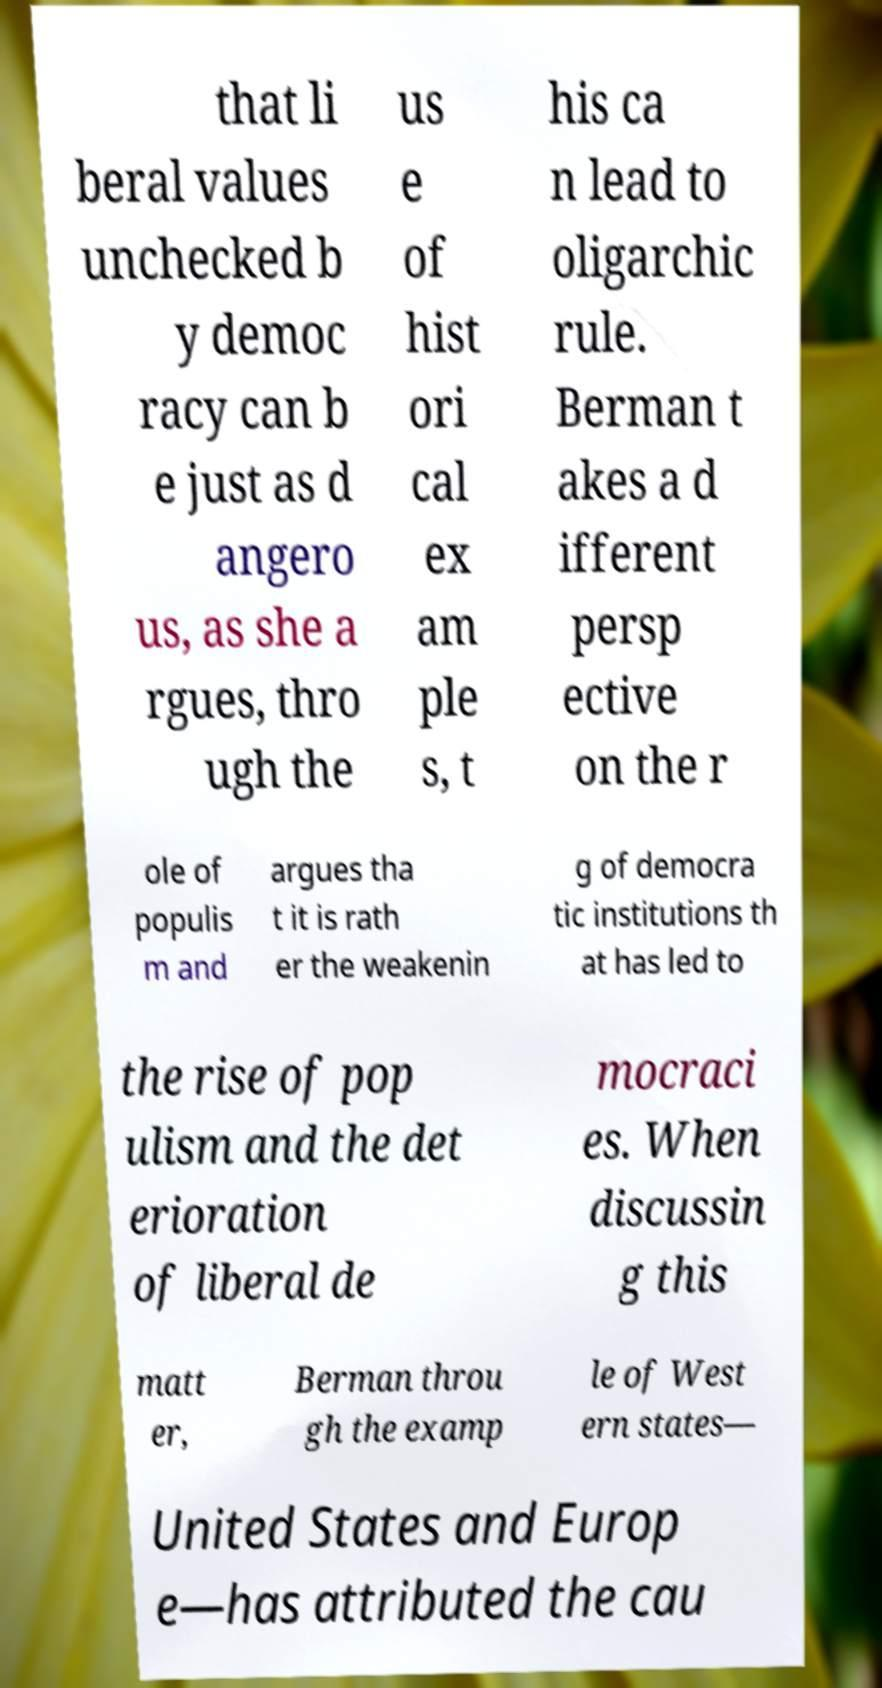There's text embedded in this image that I need extracted. Can you transcribe it verbatim? that li beral values unchecked b y democ racy can b e just as d angero us, as she a rgues, thro ugh the us e of hist ori cal ex am ple s, t his ca n lead to oligarchic rule. Berman t akes a d ifferent persp ective on the r ole of populis m and argues tha t it is rath er the weakenin g of democra tic institutions th at has led to the rise of pop ulism and the det erioration of liberal de mocraci es. When discussin g this matt er, Berman throu gh the examp le of West ern states— United States and Europ e—has attributed the cau 